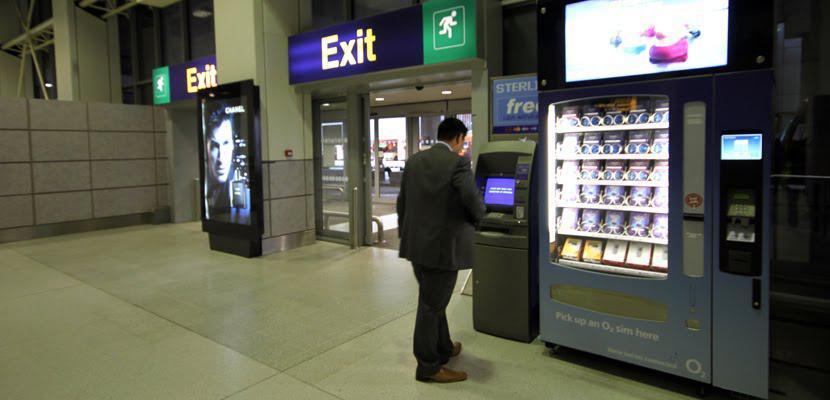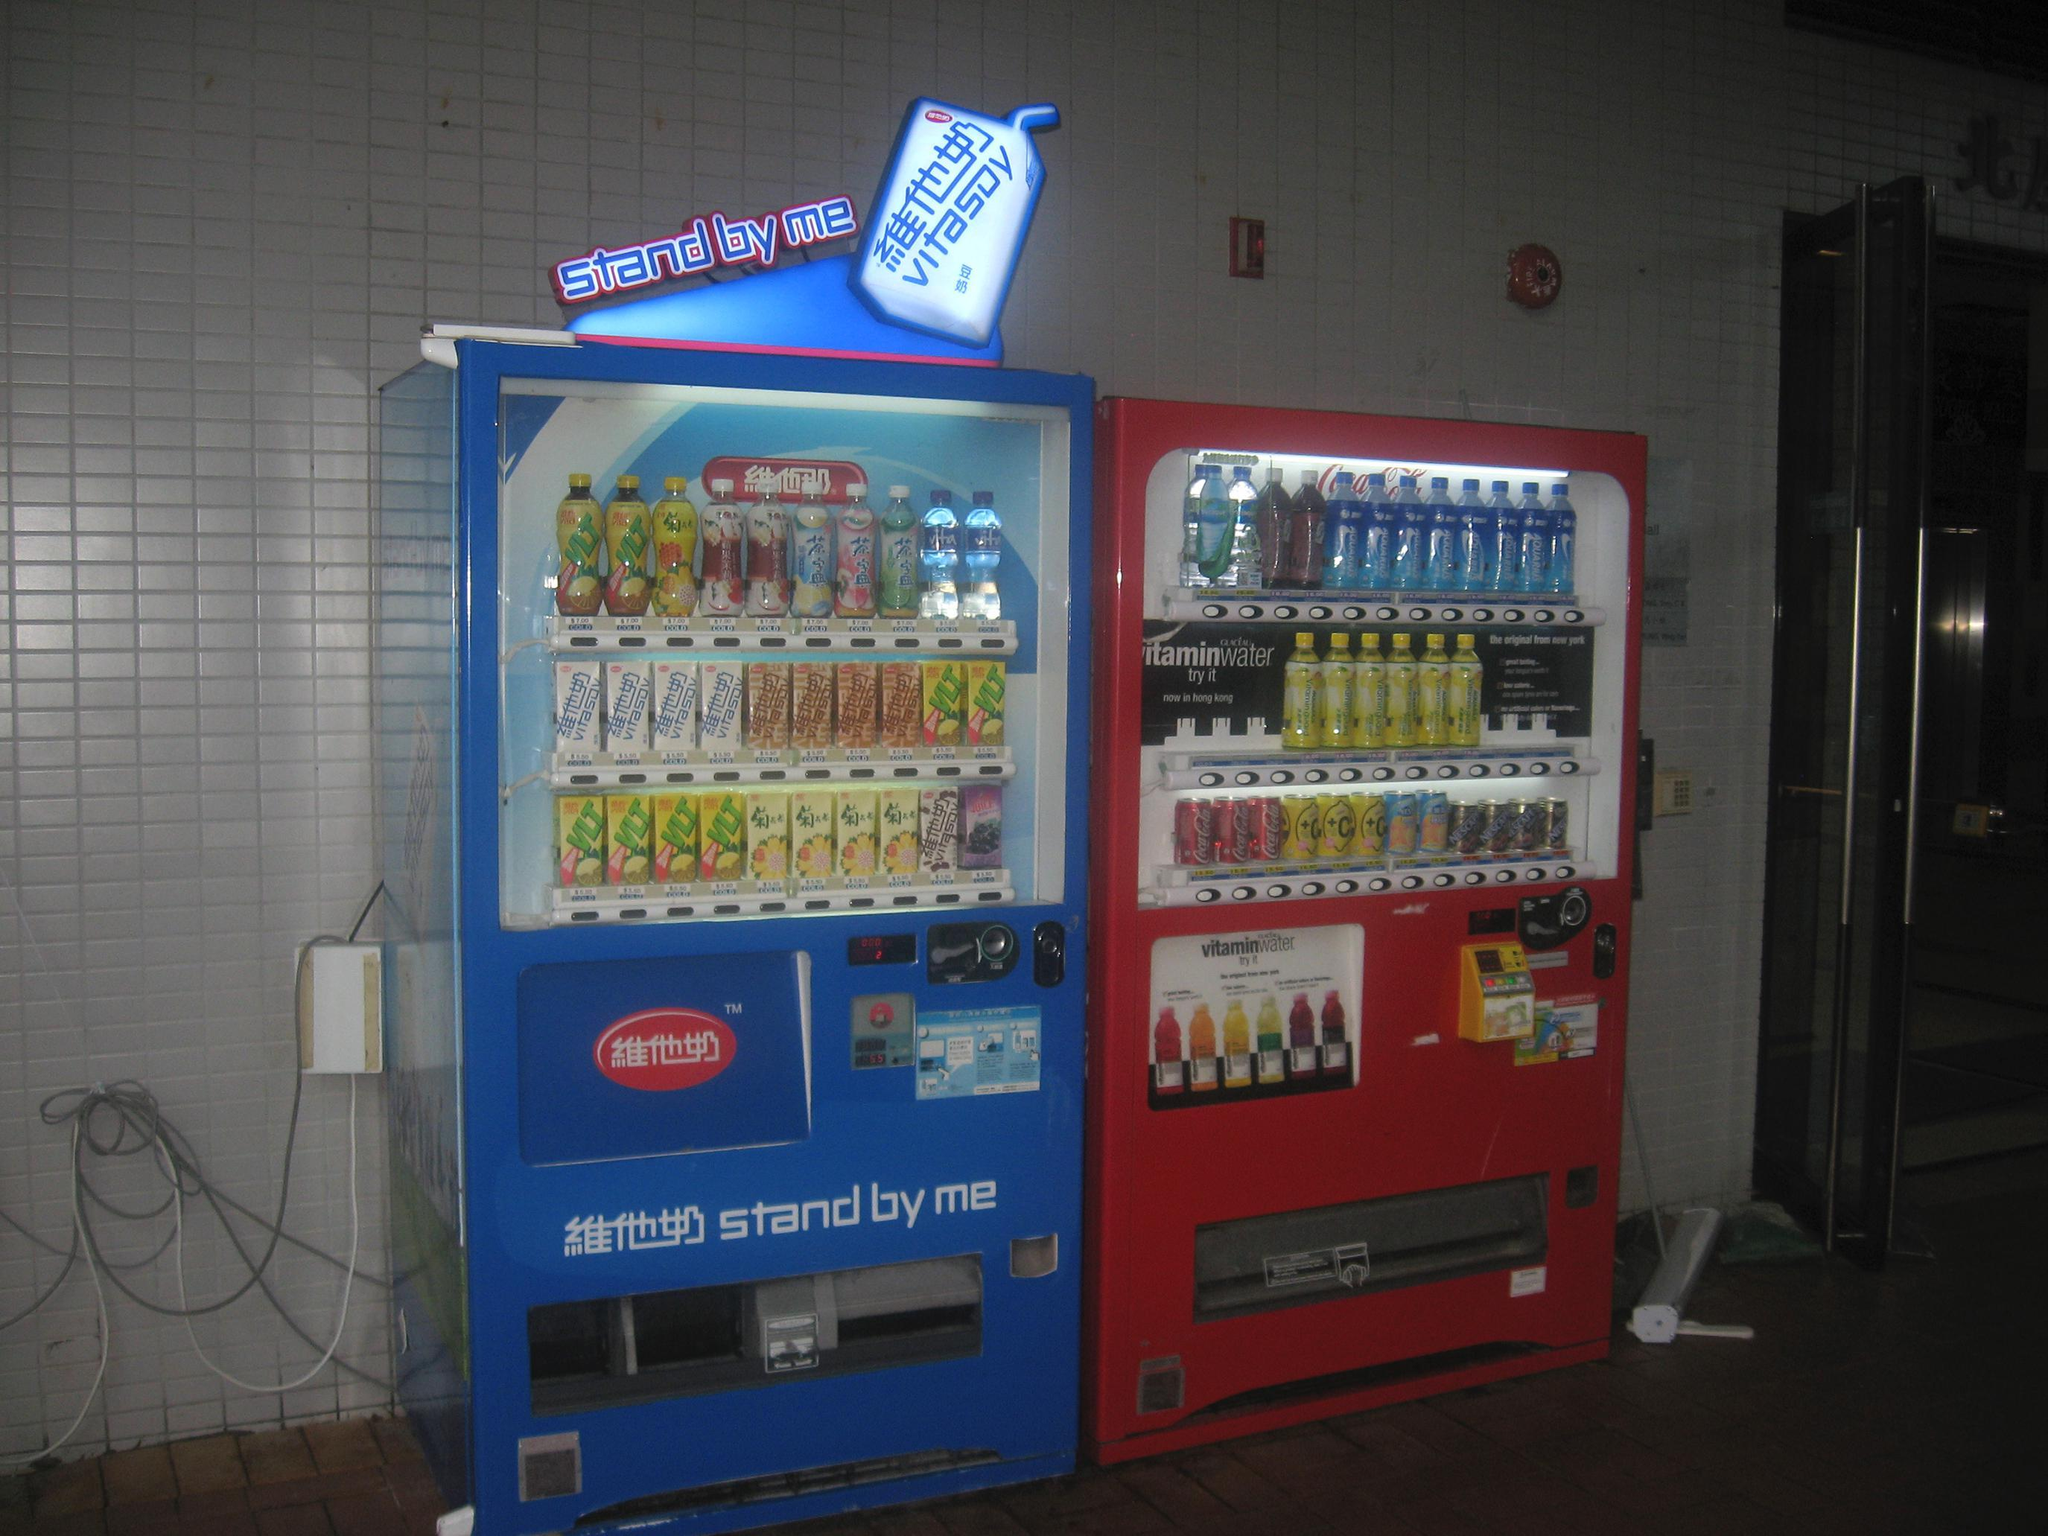The first image is the image on the left, the second image is the image on the right. Considering the images on both sides, is "A blue vending machine and a red vending machine are side by side." valid? Answer yes or no. Yes. The first image is the image on the left, the second image is the image on the right. Assess this claim about the two images: "One of the images clearly shows a blue vending machine placed directly next to a red vending machine.". Correct or not? Answer yes or no. Yes. 